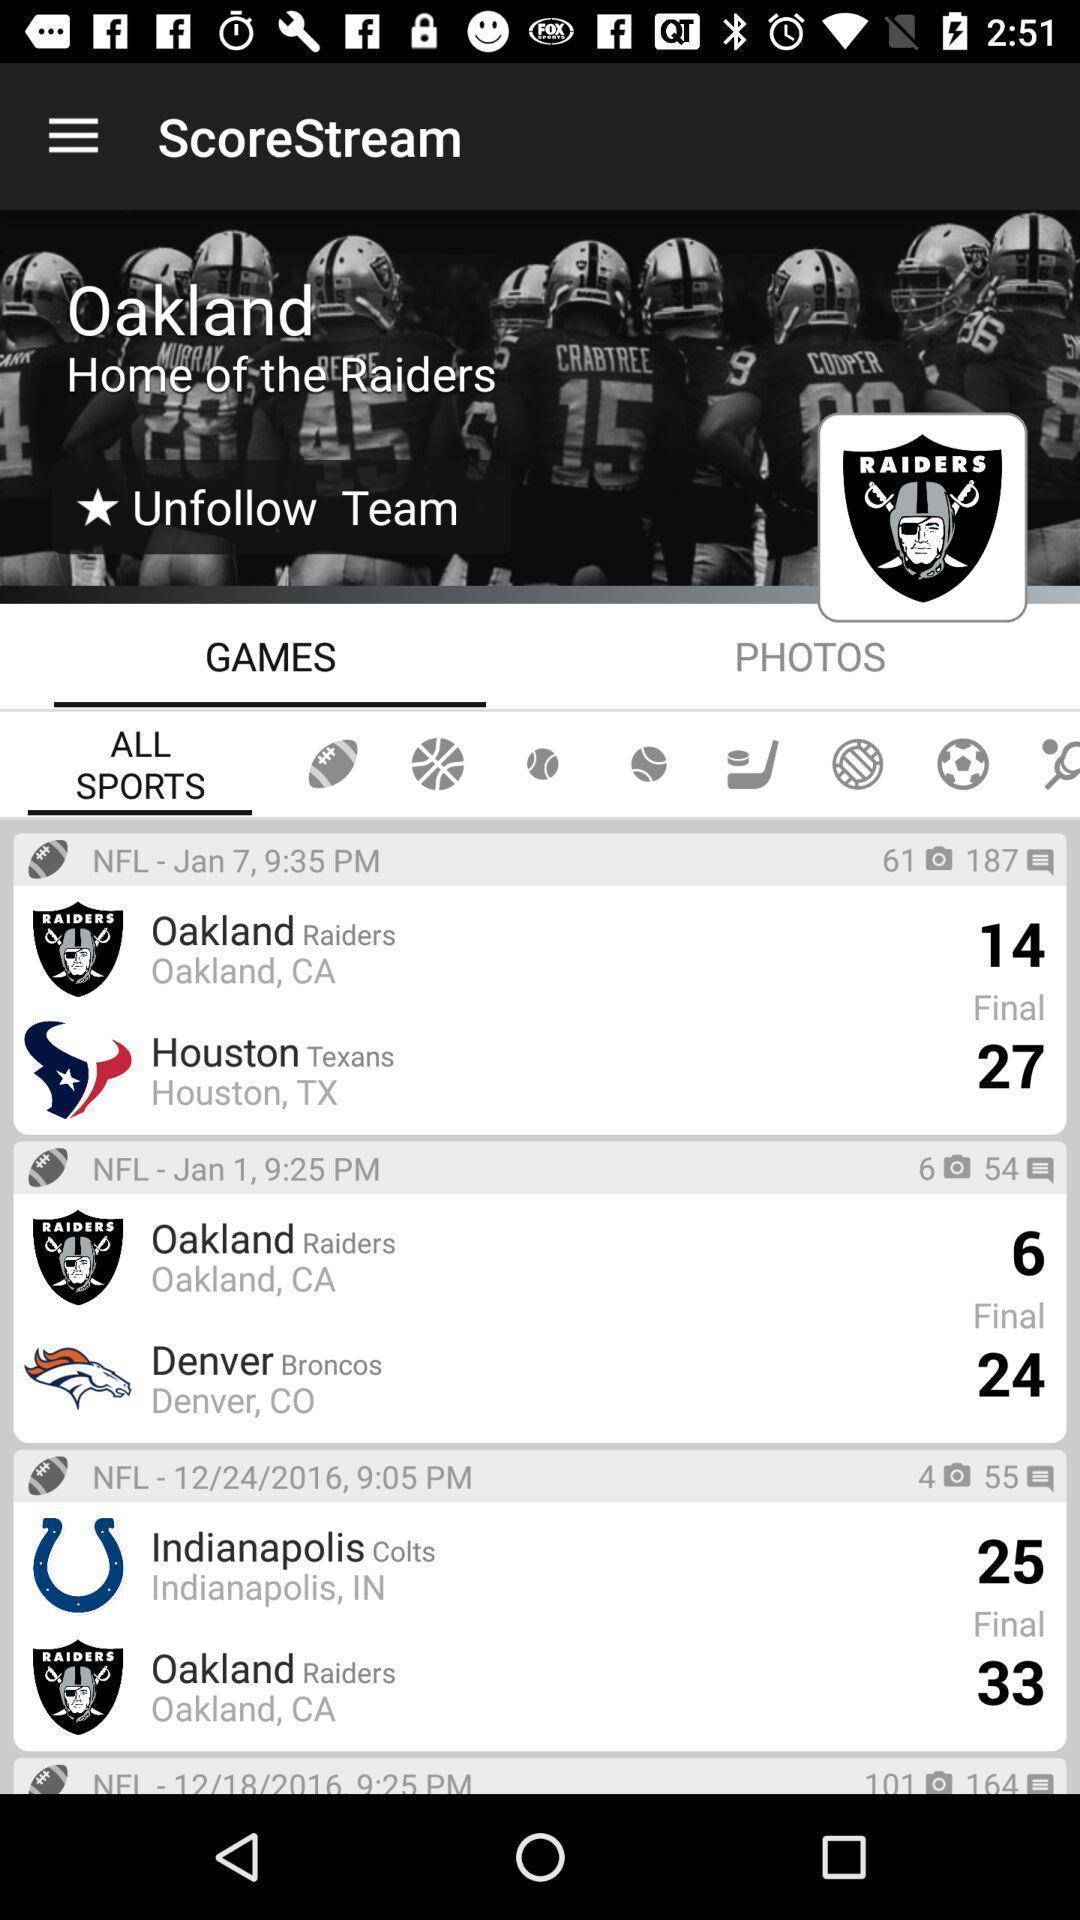Tell me about the visual elements in this screen capture. Page displaying with sports leagues information with scores. 